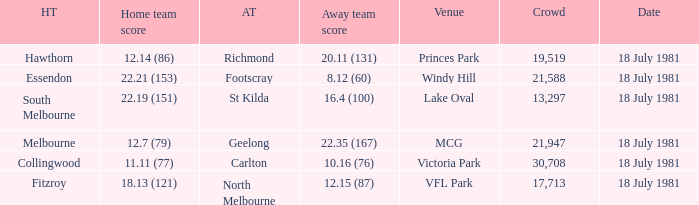When was the essendon home contest held? 18 July 1981. 